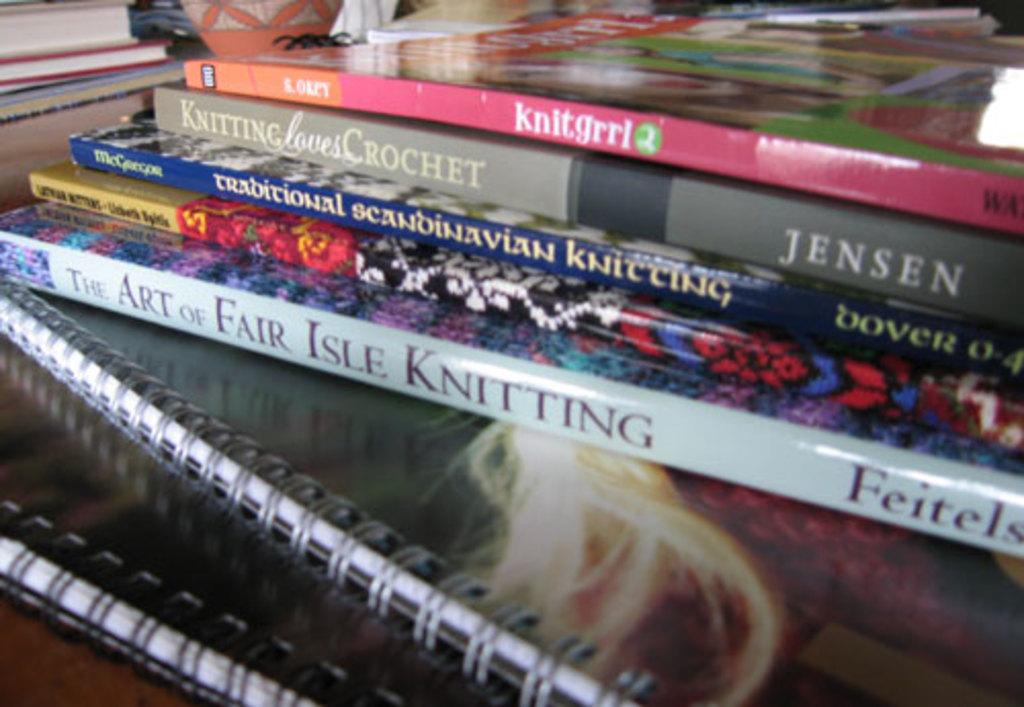What's the name of the last book?
Provide a short and direct response. The art of fair isle knitting. 